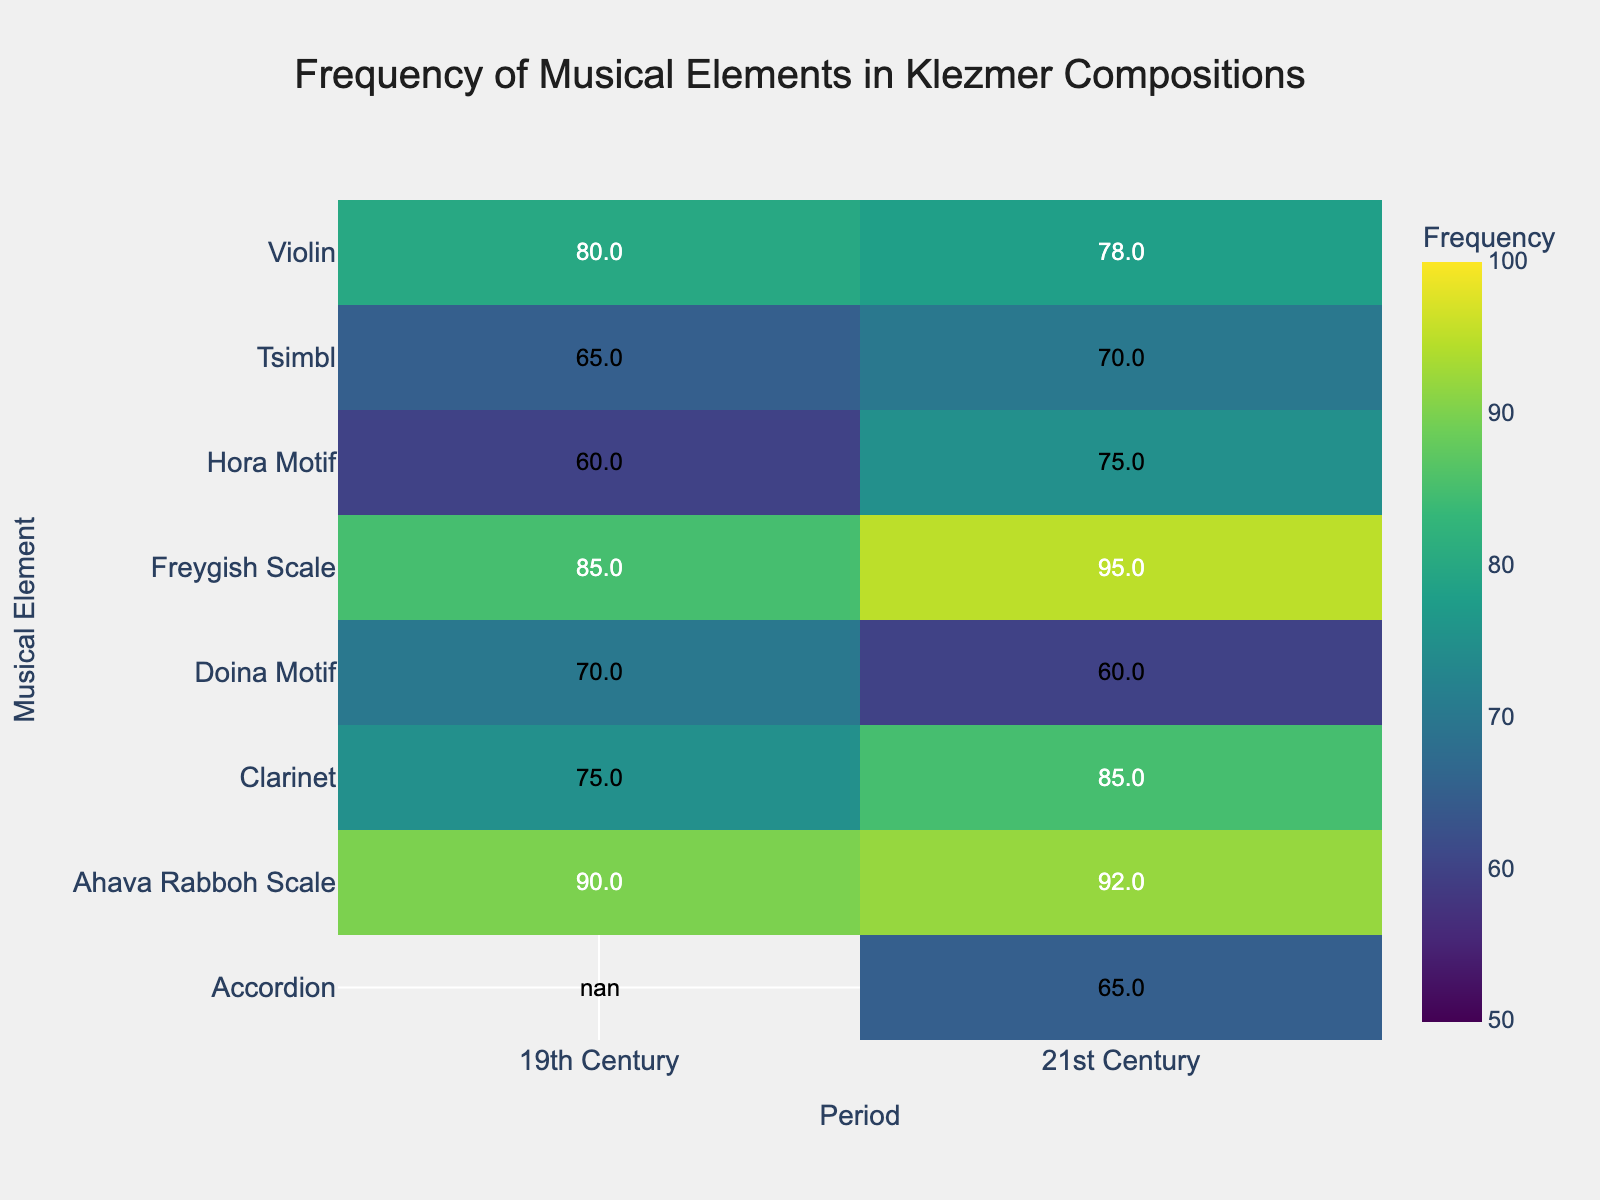which period uses the Freygish Scale more frequently? Look at the frequency values for the Freygish Scale in both periods. The 21st Century has a frequency of 95, while the 19th Century has a frequency of 85.
Answer: 21st Century What is the sum of frequencies for the Violin in both periods? Add the frequencies of the Violin for the 19th Century and 21st Century. 80 (19th Century) + 78 (21st Century) = 158.
Answer: 158 Which musical element has the lowest frequency in the 21st Century? Check the frequency values for each musical element in the 21st Century and identify the lowest. Accordion has the lowest frequency with 65.
Answer: Accordion How does the frequency of the Tsimbl compare between the 19th and 21st Century? Compare the frequency values of the Tsimbl in the 19th Century (65) and 21st Century (70). The Tsimbl has a higher frequency in the 21st Century.
Answer: 21st Century > 19th Century What is the average frequency of the Clarinet across both periods? Find the frequencies of the Clarinet in both periods and calculate the average. (75 + 85) / 2 = 80.
Answer: 80 Are there any musical elements that have a higher frequency in the 19th Century compared to the 21st Century? Compare the frequencies of each musical element across the periods. Doina Motif (70 in 19th Century, 60 in 21st Century) and Violin (80 in 19th Century, 78 in 21st Century) are higher in the 19th Century.
Answer: Doina Motif, Violin What's the frequency difference of the Hora Motif between the 19th and 21st Century? Subtract the frequency of the Hora Motif in the 19th Century (60) from that in the 21st Century (75). 75 - 60 = 15.
Answer: 15 Which musical element witnessed the highest increase in frequency from the 19th to the 21st Century? Calculate the frequency increase for each musical element and determine the highest. Freygish Scale increased by 10, Ahava Rabboh Scale by 2, Hora Motif by 15, Clarinet by 10, Tsimbl by 5. Hora Motif has the highest increase of 15.
Answer: Hora Motif Is there an instrument introduced only in the 21st Century? Check the musical elements listed in the 21st Century but not in the 19th Century. The Accordion is listed only in the 21st Century.
Answer: Yes, Accordion 